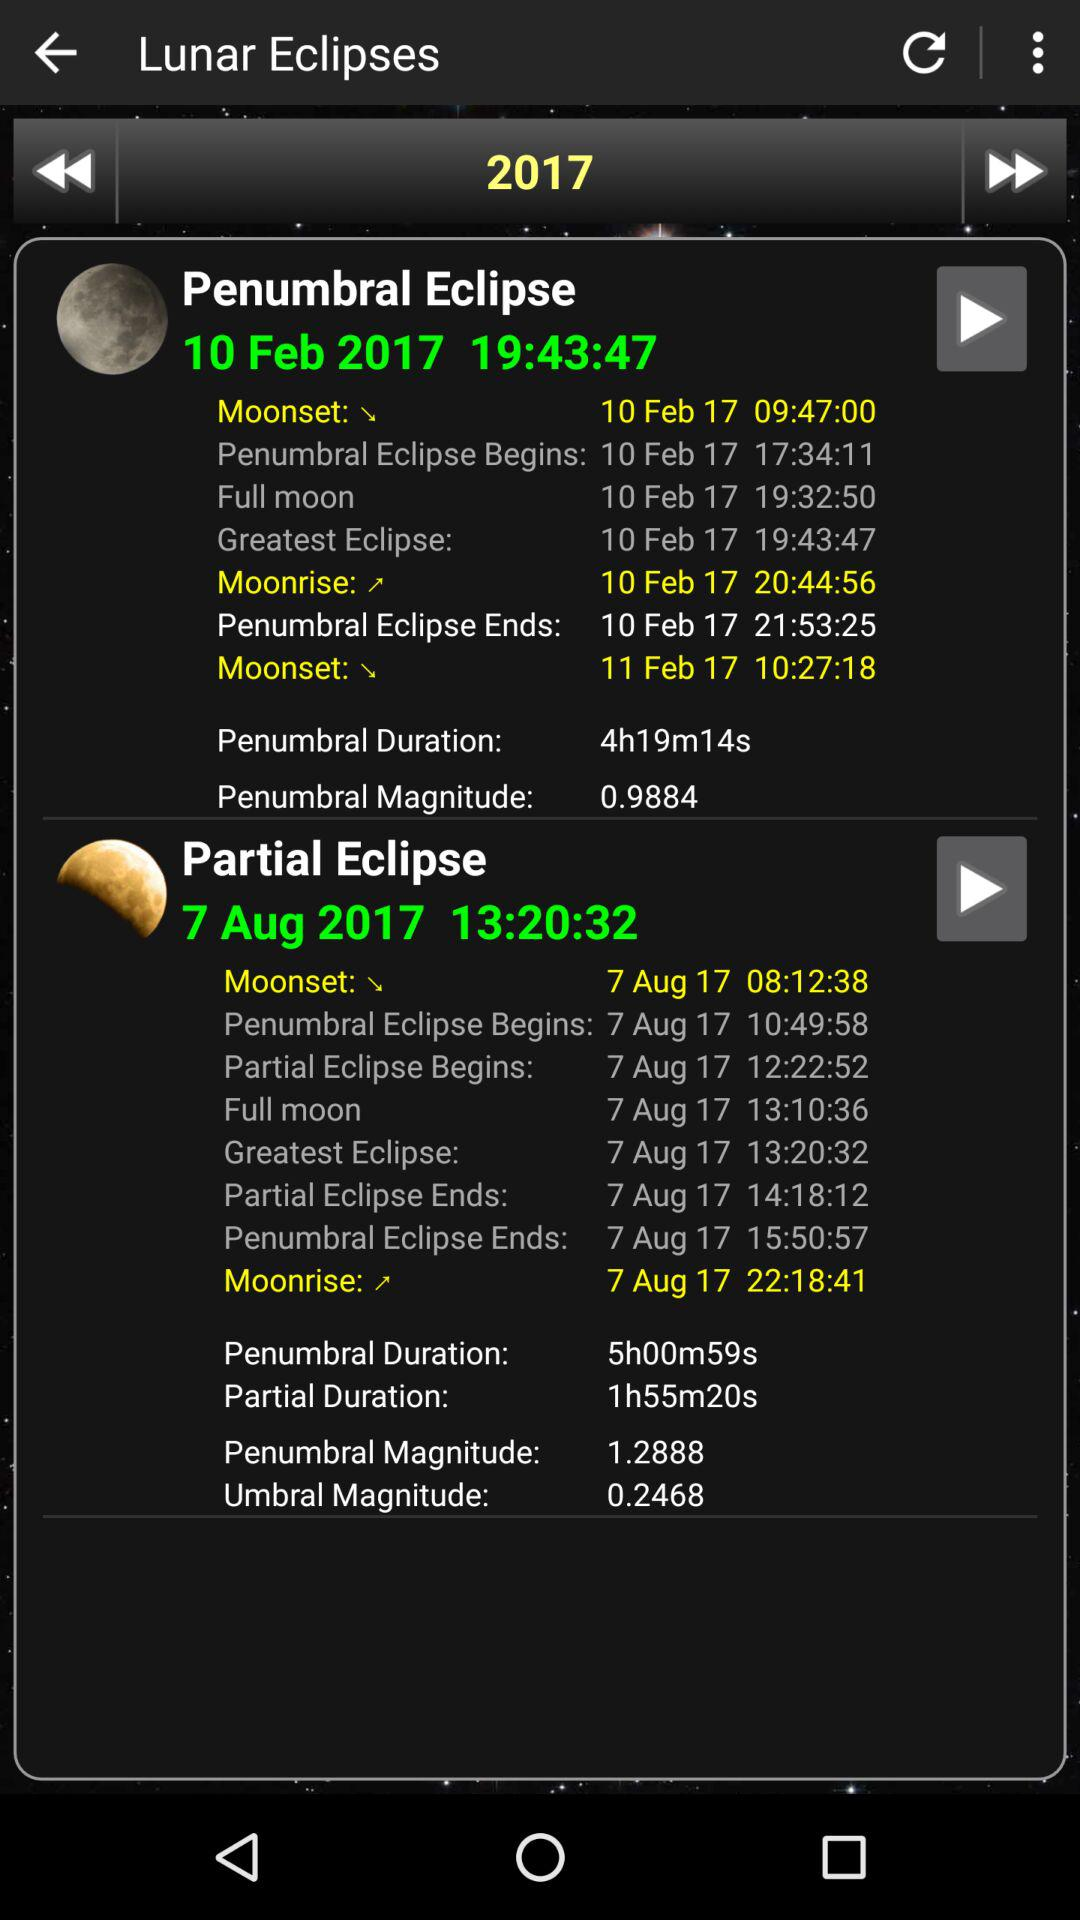What is the date of the partial eclipse? The date of the partial eclipse is August 7, 2017. 